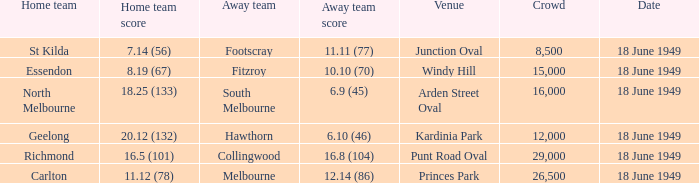What is the away team score when home team score is 20.12 (132)? 6.10 (46). 